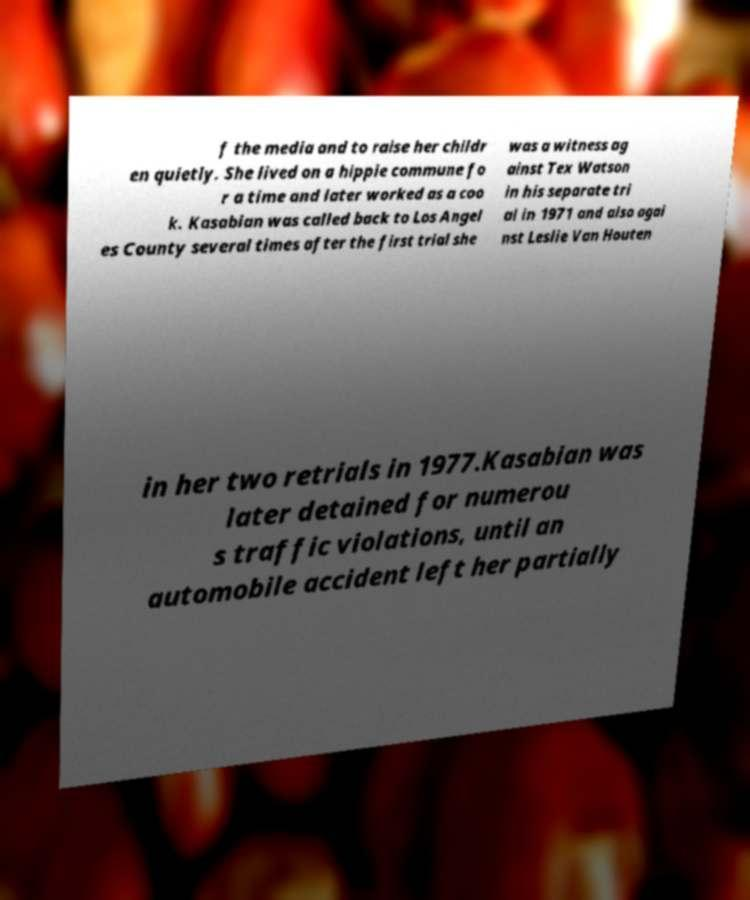For documentation purposes, I need the text within this image transcribed. Could you provide that? f the media and to raise her childr en quietly. She lived on a hippie commune fo r a time and later worked as a coo k. Kasabian was called back to Los Angel es County several times after the first trial she was a witness ag ainst Tex Watson in his separate tri al in 1971 and also agai nst Leslie Van Houten in her two retrials in 1977.Kasabian was later detained for numerou s traffic violations, until an automobile accident left her partially 